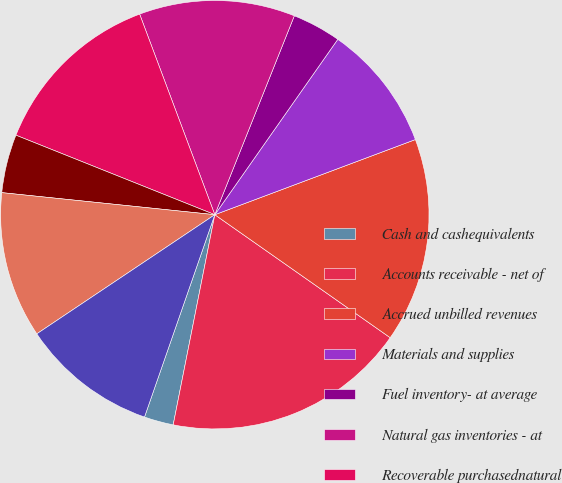<chart> <loc_0><loc_0><loc_500><loc_500><pie_chart><fcel>Cash and cashequivalents<fcel>Accounts receivable - net of<fcel>Accrued unbilled revenues<fcel>Materials and supplies<fcel>Fuel inventory- at average<fcel>Natural gas inventories - at<fcel>Recoverable purchasednatural<fcel>Derivative instruments<fcel>Prepayments and other<fcel>Currentassets held for saleand<nl><fcel>2.21%<fcel>18.38%<fcel>15.44%<fcel>9.56%<fcel>3.68%<fcel>11.76%<fcel>13.24%<fcel>4.41%<fcel>11.03%<fcel>10.29%<nl></chart> 